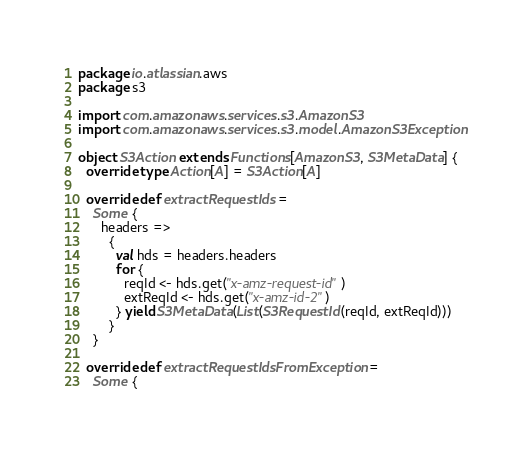Convert code to text. <code><loc_0><loc_0><loc_500><loc_500><_Scala_>package io.atlassian.aws
package s3

import com.amazonaws.services.s3.AmazonS3
import com.amazonaws.services.s3.model.AmazonS3Exception

object S3Action extends Functions[AmazonS3, S3MetaData] {
  override type Action[A] = S3Action[A]

  override def extractRequestIds =
    Some {
      headers =>
        {
          val hds = headers.headers
          for {
            reqId <- hds.get("x-amz-request-id")
            extReqId <- hds.get("x-amz-id-2")
          } yield S3MetaData(List(S3RequestId(reqId, extReqId)))
        }
    }

  override def extractRequestIdsFromException =
    Some {</code> 